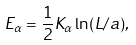<formula> <loc_0><loc_0><loc_500><loc_500>E _ { \alpha } = \frac { 1 } { 2 } K _ { \alpha } \ln ( L / a ) ,</formula> 